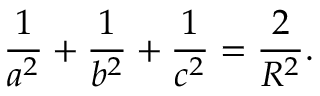<formula> <loc_0><loc_0><loc_500><loc_500>{ \frac { 1 } { a ^ { 2 } } } + { \frac { 1 } { b ^ { 2 } } } + { \frac { 1 } { c ^ { 2 } } } = { \frac { 2 } { R ^ { 2 } } } .</formula> 